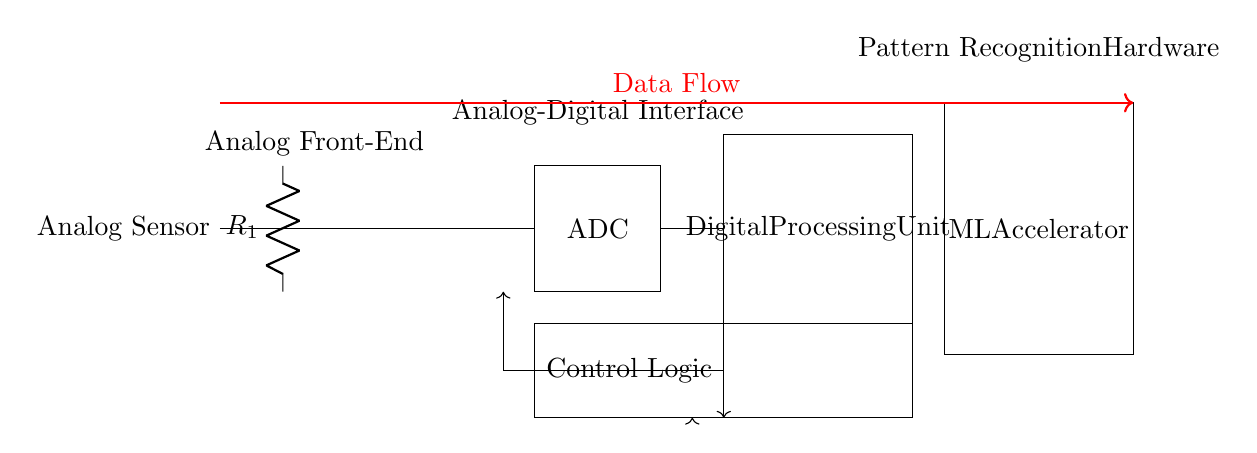What is the function of the analog sensor? The analog sensor captures real-world physical signals and converts them into an electrical signal that can be processed.
Answer: Capturing signals What component amplifies the signal in this circuit? The operational amplifier, denoted as "op amp," is designed to increase the amplitude of the signal from the analog sensor before further processing.
Answer: Operational amplifier How many main sections are in this circuit? The circuit is divided into four main sections: the analog front-end, analog-digital interface, digital processing unit, and ML accelerator.
Answer: Four What type of processing occurs in the digital processing unit? This unit is responsible for processing digital signals that have been converted from analog signals by the ADC, preparing them for machine learning applications.
Answer: Digital signal processing What is the primary role of the ADC in this circuit? The ADC, or Analog-to-Digital Converter, transforms analog signals from the amplifier into a digital format that can be utilized by digital components like the processing unit.
Answer: Signal conversion What is indicated by the red arrow in the circuit diagram? The red arrow denotes the direction of data flow through the circuit, illustrating the path that data takes from the sensor to the ML accelerator.
Answer: Data flow Which component connects directly to both control logic and the ML accelerator? The digital processing unit connects directly to the control logic below it and sends processed data to the ML accelerator.
Answer: Digital processing unit 